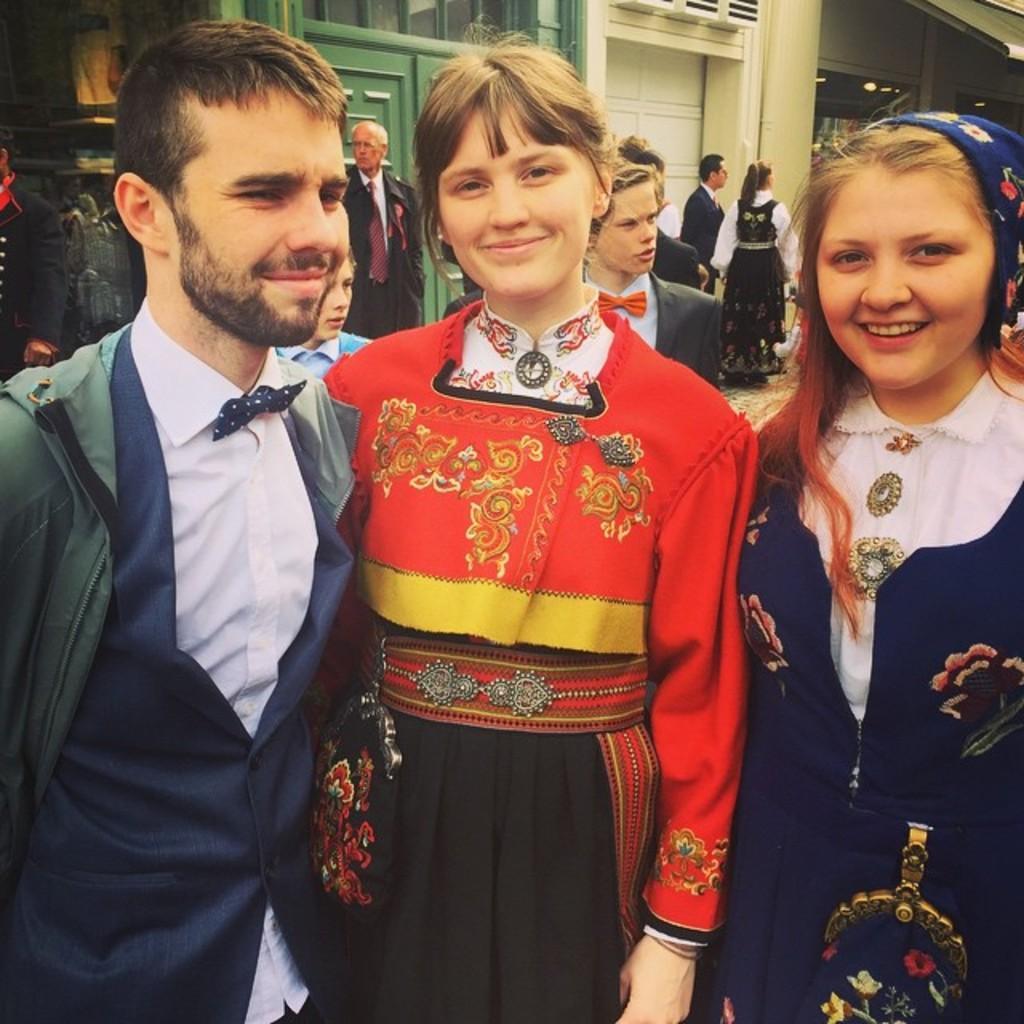Could you give a brief overview of what you see in this image? In this image there are two ladies and a man standing and giving a pose for a photograph, in the background there are people standing and there are buildings. 